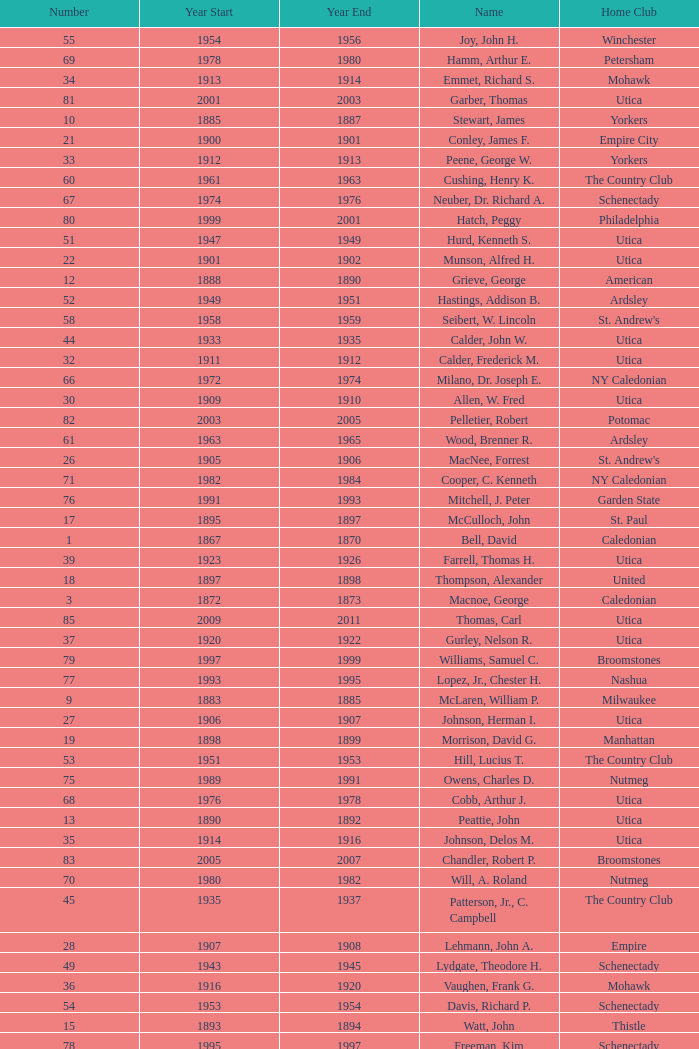Which Number has a Home Club of broomstones, and a Year End smaller than 1999? None. 